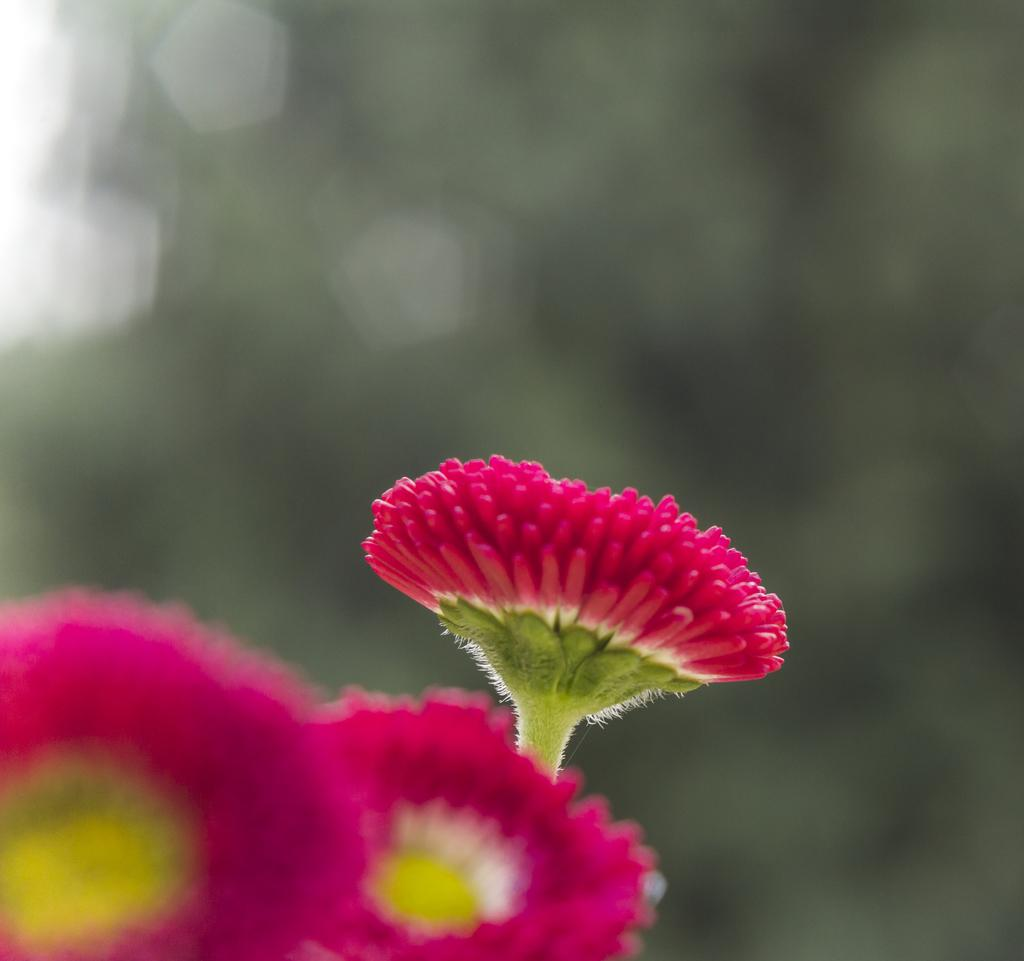What type of flowers can be seen in the image? There are three pink color flowers in the image. How many rings are visible on the bird's beak in the image? There are no birds or rings present in the image; it only features three pink color flowers. 